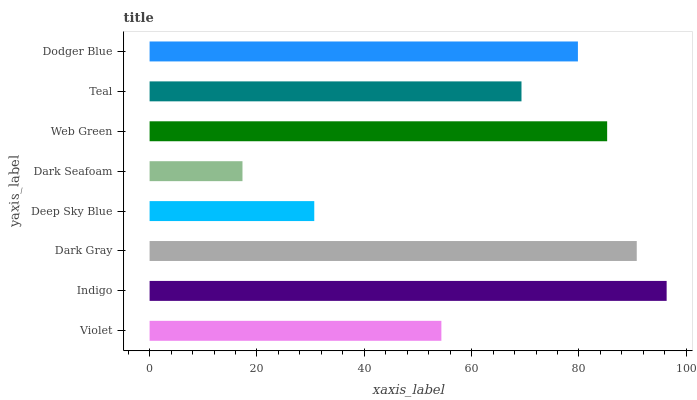Is Dark Seafoam the minimum?
Answer yes or no. Yes. Is Indigo the maximum?
Answer yes or no. Yes. Is Dark Gray the minimum?
Answer yes or no. No. Is Dark Gray the maximum?
Answer yes or no. No. Is Indigo greater than Dark Gray?
Answer yes or no. Yes. Is Dark Gray less than Indigo?
Answer yes or no. Yes. Is Dark Gray greater than Indigo?
Answer yes or no. No. Is Indigo less than Dark Gray?
Answer yes or no. No. Is Dodger Blue the high median?
Answer yes or no. Yes. Is Teal the low median?
Answer yes or no. Yes. Is Deep Sky Blue the high median?
Answer yes or no. No. Is Web Green the low median?
Answer yes or no. No. 